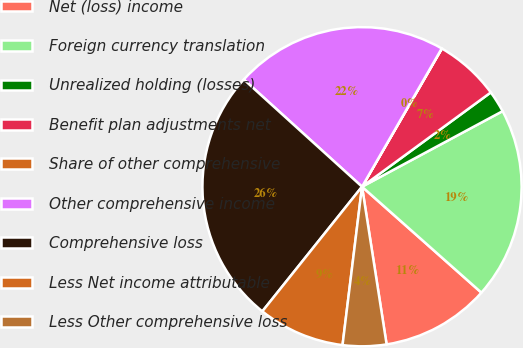<chart> <loc_0><loc_0><loc_500><loc_500><pie_chart><fcel>Net (loss) income<fcel>Foreign currency translation<fcel>Unrealized holding (losses)<fcel>Benefit plan adjustments net<fcel>Share of other comprehensive<fcel>Other comprehensive income<fcel>Comprehensive loss<fcel>Less Net income attributable<fcel>Less Other comprehensive loss<nl><fcel>10.99%<fcel>19.4%<fcel>2.21%<fcel>6.6%<fcel>0.02%<fcel>21.6%<fcel>25.99%<fcel>8.79%<fcel>4.41%<nl></chart> 